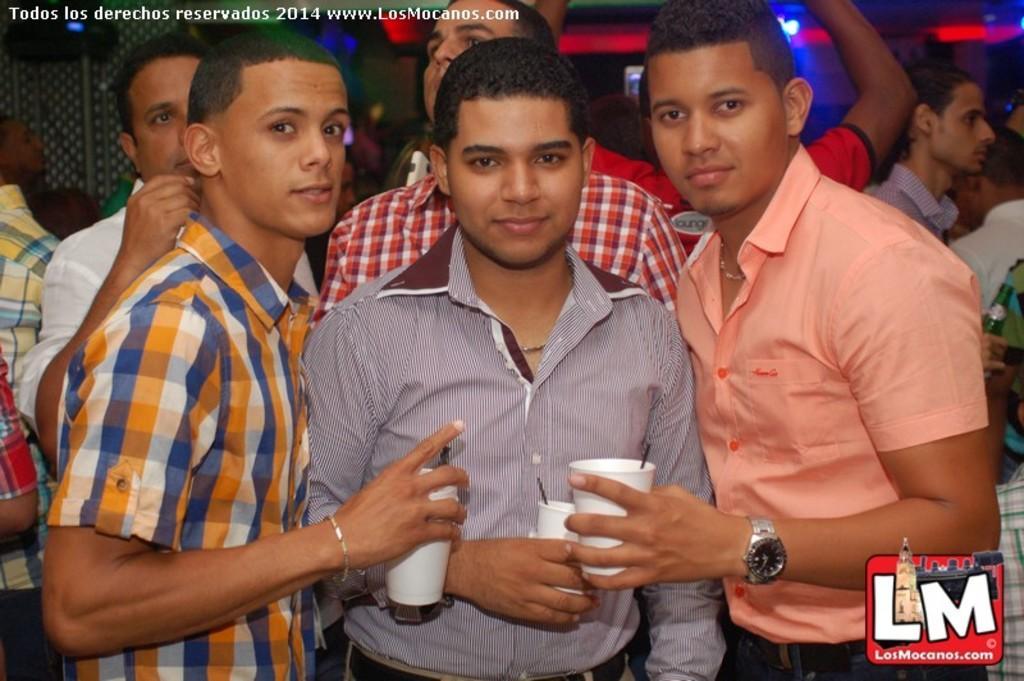How would you summarize this image in a sentence or two? In the picture I can see these three persons wearing shirts are holding white color glasses in their hands. In the background, I can see a few more people standing and I can see show lights. Here I can see the watermark at the top left side of the image and I can see a logo at the bottom right side of the image. 